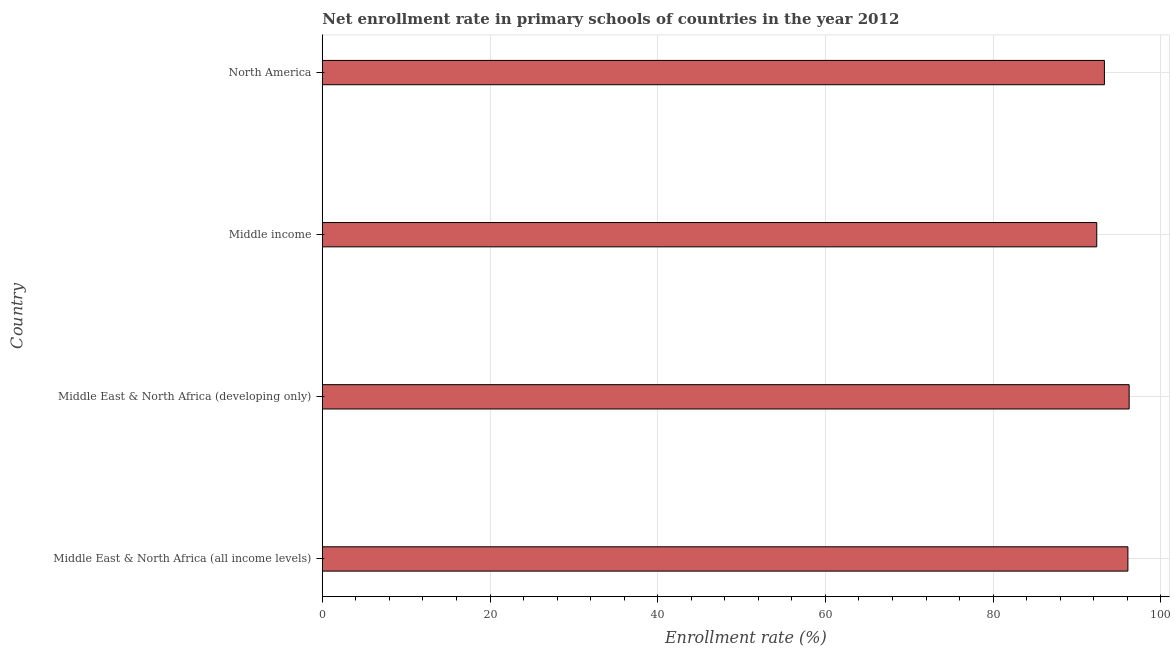Does the graph contain grids?
Make the answer very short. Yes. What is the title of the graph?
Your response must be concise. Net enrollment rate in primary schools of countries in the year 2012. What is the label or title of the X-axis?
Provide a short and direct response. Enrollment rate (%). What is the net enrollment rate in primary schools in North America?
Give a very brief answer. 93.27. Across all countries, what is the maximum net enrollment rate in primary schools?
Provide a succinct answer. 96.22. Across all countries, what is the minimum net enrollment rate in primary schools?
Offer a terse response. 92.36. In which country was the net enrollment rate in primary schools maximum?
Ensure brevity in your answer.  Middle East & North Africa (developing only). What is the sum of the net enrollment rate in primary schools?
Make the answer very short. 377.92. What is the difference between the net enrollment rate in primary schools in Middle income and North America?
Provide a succinct answer. -0.91. What is the average net enrollment rate in primary schools per country?
Keep it short and to the point. 94.48. What is the median net enrollment rate in primary schools?
Your response must be concise. 94.67. In how many countries, is the net enrollment rate in primary schools greater than 60 %?
Provide a short and direct response. 4. What is the ratio of the net enrollment rate in primary schools in Middle East & North Africa (developing only) to that in Middle income?
Offer a terse response. 1.04. What is the difference between the highest and the second highest net enrollment rate in primary schools?
Provide a short and direct response. 0.15. Is the sum of the net enrollment rate in primary schools in Middle East & North Africa (all income levels) and Middle income greater than the maximum net enrollment rate in primary schools across all countries?
Make the answer very short. Yes. What is the difference between the highest and the lowest net enrollment rate in primary schools?
Offer a terse response. 3.86. In how many countries, is the net enrollment rate in primary schools greater than the average net enrollment rate in primary schools taken over all countries?
Offer a terse response. 2. How many bars are there?
Your answer should be very brief. 4. Are the values on the major ticks of X-axis written in scientific E-notation?
Offer a terse response. No. What is the Enrollment rate (%) of Middle East & North Africa (all income levels)?
Provide a short and direct response. 96.07. What is the Enrollment rate (%) in Middle East & North Africa (developing only)?
Your answer should be compact. 96.22. What is the Enrollment rate (%) in Middle income?
Provide a succinct answer. 92.36. What is the Enrollment rate (%) in North America?
Make the answer very short. 93.27. What is the difference between the Enrollment rate (%) in Middle East & North Africa (all income levels) and Middle East & North Africa (developing only)?
Your response must be concise. -0.15. What is the difference between the Enrollment rate (%) in Middle East & North Africa (all income levels) and Middle income?
Your response must be concise. 3.72. What is the difference between the Enrollment rate (%) in Middle East & North Africa (all income levels) and North America?
Your response must be concise. 2.8. What is the difference between the Enrollment rate (%) in Middle East & North Africa (developing only) and Middle income?
Your answer should be compact. 3.86. What is the difference between the Enrollment rate (%) in Middle East & North Africa (developing only) and North America?
Your response must be concise. 2.95. What is the difference between the Enrollment rate (%) in Middle income and North America?
Offer a very short reply. -0.91. What is the ratio of the Enrollment rate (%) in Middle East & North Africa (all income levels) to that in Middle East & North Africa (developing only)?
Provide a succinct answer. 1. What is the ratio of the Enrollment rate (%) in Middle East & North Africa (all income levels) to that in North America?
Offer a very short reply. 1.03. What is the ratio of the Enrollment rate (%) in Middle East & North Africa (developing only) to that in Middle income?
Your response must be concise. 1.04. What is the ratio of the Enrollment rate (%) in Middle East & North Africa (developing only) to that in North America?
Ensure brevity in your answer.  1.03. 